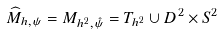<formula> <loc_0><loc_0><loc_500><loc_500>\widehat { M } _ { h , \psi } = M _ { h ^ { 2 } , \hat { \psi } } = T _ { h ^ { 2 } } \cup D ^ { 2 } \times S ^ { 2 }</formula> 